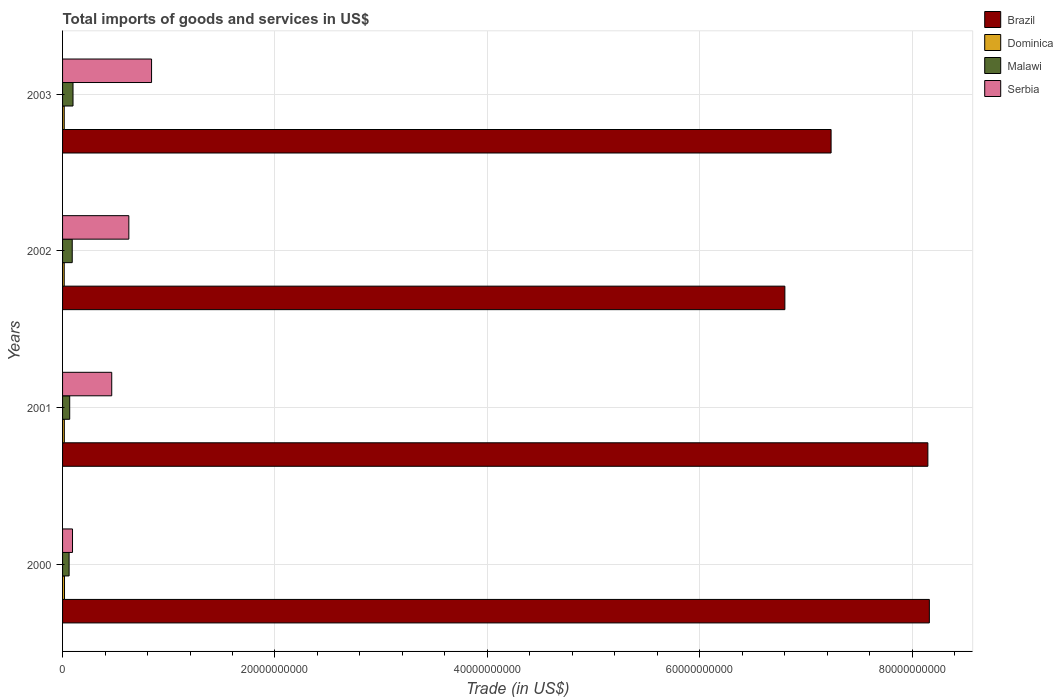How many bars are there on the 3rd tick from the top?
Give a very brief answer. 4. In how many cases, is the number of bars for a given year not equal to the number of legend labels?
Your answer should be compact. 0. What is the total imports of goods and services in Malawi in 2002?
Your answer should be very brief. 9.10e+08. Across all years, what is the maximum total imports of goods and services in Serbia?
Give a very brief answer. 8.38e+09. Across all years, what is the minimum total imports of goods and services in Serbia?
Provide a succinct answer. 9.36e+08. In which year was the total imports of goods and services in Malawi maximum?
Offer a terse response. 2003. What is the total total imports of goods and services in Serbia in the graph?
Give a very brief answer. 2.02e+1. What is the difference between the total imports of goods and services in Dominica in 2002 and that in 2003?
Ensure brevity in your answer.  -1.10e+06. What is the difference between the total imports of goods and services in Serbia in 2001 and the total imports of goods and services in Malawi in 2002?
Offer a terse response. 3.72e+09. What is the average total imports of goods and services in Malawi per year?
Your response must be concise. 7.96e+08. In the year 2001, what is the difference between the total imports of goods and services in Dominica and total imports of goods and services in Serbia?
Offer a very short reply. -4.46e+09. What is the ratio of the total imports of goods and services in Malawi in 2000 to that in 2003?
Give a very brief answer. 0.63. Is the total imports of goods and services in Dominica in 2000 less than that in 2001?
Provide a succinct answer. No. Is the difference between the total imports of goods and services in Dominica in 2001 and 2002 greater than the difference between the total imports of goods and services in Serbia in 2001 and 2002?
Offer a terse response. Yes. What is the difference between the highest and the second highest total imports of goods and services in Dominica?
Give a very brief answer. 1.73e+07. What is the difference between the highest and the lowest total imports of goods and services in Serbia?
Ensure brevity in your answer.  7.44e+09. Is the sum of the total imports of goods and services in Serbia in 2000 and 2002 greater than the maximum total imports of goods and services in Brazil across all years?
Your answer should be compact. No. Is it the case that in every year, the sum of the total imports of goods and services in Brazil and total imports of goods and services in Malawi is greater than the sum of total imports of goods and services in Serbia and total imports of goods and services in Dominica?
Provide a short and direct response. Yes. What does the 1st bar from the top in 2000 represents?
Provide a succinct answer. Serbia. What does the 2nd bar from the bottom in 2001 represents?
Make the answer very short. Dominica. How many bars are there?
Offer a terse response. 16. Are all the bars in the graph horizontal?
Provide a succinct answer. Yes. What is the difference between two consecutive major ticks on the X-axis?
Offer a terse response. 2.00e+1. Does the graph contain any zero values?
Provide a short and direct response. No. Where does the legend appear in the graph?
Offer a terse response. Top right. How many legend labels are there?
Make the answer very short. 4. What is the title of the graph?
Offer a terse response. Total imports of goods and services in US$. Does "Nicaragua" appear as one of the legend labels in the graph?
Make the answer very short. No. What is the label or title of the X-axis?
Your response must be concise. Trade (in US$). What is the label or title of the Y-axis?
Ensure brevity in your answer.  Years. What is the Trade (in US$) in Brazil in 2000?
Your answer should be compact. 8.16e+1. What is the Trade (in US$) of Dominica in 2000?
Give a very brief answer. 1.83e+08. What is the Trade (in US$) in Malawi in 2000?
Give a very brief answer. 6.16e+08. What is the Trade (in US$) in Serbia in 2000?
Provide a succinct answer. 9.36e+08. What is the Trade (in US$) of Brazil in 2001?
Offer a very short reply. 8.15e+1. What is the Trade (in US$) of Dominica in 2001?
Your answer should be compact. 1.66e+08. What is the Trade (in US$) of Malawi in 2001?
Ensure brevity in your answer.  6.72e+08. What is the Trade (in US$) in Serbia in 2001?
Your response must be concise. 4.63e+09. What is the Trade (in US$) in Brazil in 2002?
Make the answer very short. 6.80e+1. What is the Trade (in US$) in Dominica in 2002?
Offer a terse response. 1.56e+08. What is the Trade (in US$) of Malawi in 2002?
Give a very brief answer. 9.10e+08. What is the Trade (in US$) in Serbia in 2002?
Your response must be concise. 6.24e+09. What is the Trade (in US$) of Brazil in 2003?
Ensure brevity in your answer.  7.24e+1. What is the Trade (in US$) of Dominica in 2003?
Make the answer very short. 1.57e+08. What is the Trade (in US$) in Malawi in 2003?
Your answer should be compact. 9.84e+08. What is the Trade (in US$) of Serbia in 2003?
Offer a terse response. 8.38e+09. Across all years, what is the maximum Trade (in US$) in Brazil?
Your response must be concise. 8.16e+1. Across all years, what is the maximum Trade (in US$) of Dominica?
Make the answer very short. 1.83e+08. Across all years, what is the maximum Trade (in US$) in Malawi?
Ensure brevity in your answer.  9.84e+08. Across all years, what is the maximum Trade (in US$) in Serbia?
Offer a terse response. 8.38e+09. Across all years, what is the minimum Trade (in US$) in Brazil?
Ensure brevity in your answer.  6.80e+1. Across all years, what is the minimum Trade (in US$) in Dominica?
Keep it short and to the point. 1.56e+08. Across all years, what is the minimum Trade (in US$) in Malawi?
Provide a succinct answer. 6.16e+08. Across all years, what is the minimum Trade (in US$) of Serbia?
Give a very brief answer. 9.36e+08. What is the total Trade (in US$) in Brazil in the graph?
Ensure brevity in your answer.  3.03e+11. What is the total Trade (in US$) of Dominica in the graph?
Your response must be concise. 6.62e+08. What is the total Trade (in US$) of Malawi in the graph?
Give a very brief answer. 3.18e+09. What is the total Trade (in US$) of Serbia in the graph?
Provide a succinct answer. 2.02e+1. What is the difference between the Trade (in US$) of Brazil in 2000 and that in 2001?
Your response must be concise. 1.39e+08. What is the difference between the Trade (in US$) of Dominica in 2000 and that in 2001?
Offer a very short reply. 1.73e+07. What is the difference between the Trade (in US$) of Malawi in 2000 and that in 2001?
Offer a very short reply. -5.56e+07. What is the difference between the Trade (in US$) of Serbia in 2000 and that in 2001?
Your answer should be very brief. -3.69e+09. What is the difference between the Trade (in US$) in Brazil in 2000 and that in 2002?
Your answer should be compact. 1.36e+1. What is the difference between the Trade (in US$) in Dominica in 2000 and that in 2002?
Your answer should be compact. 2.68e+07. What is the difference between the Trade (in US$) of Malawi in 2000 and that in 2002?
Your answer should be compact. -2.94e+08. What is the difference between the Trade (in US$) in Serbia in 2000 and that in 2002?
Keep it short and to the point. -5.30e+09. What is the difference between the Trade (in US$) in Brazil in 2000 and that in 2003?
Give a very brief answer. 9.25e+09. What is the difference between the Trade (in US$) of Dominica in 2000 and that in 2003?
Keep it short and to the point. 2.57e+07. What is the difference between the Trade (in US$) in Malawi in 2000 and that in 2003?
Offer a very short reply. -3.68e+08. What is the difference between the Trade (in US$) of Serbia in 2000 and that in 2003?
Your response must be concise. -7.44e+09. What is the difference between the Trade (in US$) of Brazil in 2001 and that in 2002?
Your response must be concise. 1.35e+1. What is the difference between the Trade (in US$) of Dominica in 2001 and that in 2002?
Keep it short and to the point. 9.51e+06. What is the difference between the Trade (in US$) in Malawi in 2001 and that in 2002?
Provide a short and direct response. -2.39e+08. What is the difference between the Trade (in US$) in Serbia in 2001 and that in 2002?
Offer a very short reply. -1.61e+09. What is the difference between the Trade (in US$) of Brazil in 2001 and that in 2003?
Keep it short and to the point. 9.11e+09. What is the difference between the Trade (in US$) in Dominica in 2001 and that in 2003?
Keep it short and to the point. 8.41e+06. What is the difference between the Trade (in US$) of Malawi in 2001 and that in 2003?
Your response must be concise. -3.13e+08. What is the difference between the Trade (in US$) of Serbia in 2001 and that in 2003?
Give a very brief answer. -3.75e+09. What is the difference between the Trade (in US$) in Brazil in 2002 and that in 2003?
Provide a short and direct response. -4.35e+09. What is the difference between the Trade (in US$) in Dominica in 2002 and that in 2003?
Your answer should be very brief. -1.10e+06. What is the difference between the Trade (in US$) of Malawi in 2002 and that in 2003?
Your answer should be compact. -7.41e+07. What is the difference between the Trade (in US$) in Serbia in 2002 and that in 2003?
Give a very brief answer. -2.14e+09. What is the difference between the Trade (in US$) in Brazil in 2000 and the Trade (in US$) in Dominica in 2001?
Your answer should be very brief. 8.15e+1. What is the difference between the Trade (in US$) of Brazil in 2000 and the Trade (in US$) of Malawi in 2001?
Offer a terse response. 8.09e+1. What is the difference between the Trade (in US$) of Brazil in 2000 and the Trade (in US$) of Serbia in 2001?
Give a very brief answer. 7.70e+1. What is the difference between the Trade (in US$) of Dominica in 2000 and the Trade (in US$) of Malawi in 2001?
Keep it short and to the point. -4.89e+08. What is the difference between the Trade (in US$) in Dominica in 2000 and the Trade (in US$) in Serbia in 2001?
Give a very brief answer. -4.45e+09. What is the difference between the Trade (in US$) of Malawi in 2000 and the Trade (in US$) of Serbia in 2001?
Give a very brief answer. -4.01e+09. What is the difference between the Trade (in US$) of Brazil in 2000 and the Trade (in US$) of Dominica in 2002?
Give a very brief answer. 8.15e+1. What is the difference between the Trade (in US$) of Brazil in 2000 and the Trade (in US$) of Malawi in 2002?
Ensure brevity in your answer.  8.07e+1. What is the difference between the Trade (in US$) in Brazil in 2000 and the Trade (in US$) in Serbia in 2002?
Offer a terse response. 7.54e+1. What is the difference between the Trade (in US$) in Dominica in 2000 and the Trade (in US$) in Malawi in 2002?
Your answer should be very brief. -7.27e+08. What is the difference between the Trade (in US$) in Dominica in 2000 and the Trade (in US$) in Serbia in 2002?
Your answer should be compact. -6.06e+09. What is the difference between the Trade (in US$) of Malawi in 2000 and the Trade (in US$) of Serbia in 2002?
Ensure brevity in your answer.  -5.63e+09. What is the difference between the Trade (in US$) of Brazil in 2000 and the Trade (in US$) of Dominica in 2003?
Your answer should be compact. 8.15e+1. What is the difference between the Trade (in US$) in Brazil in 2000 and the Trade (in US$) in Malawi in 2003?
Provide a short and direct response. 8.06e+1. What is the difference between the Trade (in US$) of Brazil in 2000 and the Trade (in US$) of Serbia in 2003?
Keep it short and to the point. 7.32e+1. What is the difference between the Trade (in US$) of Dominica in 2000 and the Trade (in US$) of Malawi in 2003?
Your response must be concise. -8.01e+08. What is the difference between the Trade (in US$) in Dominica in 2000 and the Trade (in US$) in Serbia in 2003?
Ensure brevity in your answer.  -8.20e+09. What is the difference between the Trade (in US$) of Malawi in 2000 and the Trade (in US$) of Serbia in 2003?
Make the answer very short. -7.76e+09. What is the difference between the Trade (in US$) of Brazil in 2001 and the Trade (in US$) of Dominica in 2002?
Give a very brief answer. 8.13e+1. What is the difference between the Trade (in US$) of Brazil in 2001 and the Trade (in US$) of Malawi in 2002?
Your answer should be compact. 8.06e+1. What is the difference between the Trade (in US$) in Brazil in 2001 and the Trade (in US$) in Serbia in 2002?
Keep it short and to the point. 7.52e+1. What is the difference between the Trade (in US$) of Dominica in 2001 and the Trade (in US$) of Malawi in 2002?
Give a very brief answer. -7.45e+08. What is the difference between the Trade (in US$) of Dominica in 2001 and the Trade (in US$) of Serbia in 2002?
Ensure brevity in your answer.  -6.08e+09. What is the difference between the Trade (in US$) of Malawi in 2001 and the Trade (in US$) of Serbia in 2002?
Provide a short and direct response. -5.57e+09. What is the difference between the Trade (in US$) of Brazil in 2001 and the Trade (in US$) of Dominica in 2003?
Your answer should be compact. 8.13e+1. What is the difference between the Trade (in US$) in Brazil in 2001 and the Trade (in US$) in Malawi in 2003?
Ensure brevity in your answer.  8.05e+1. What is the difference between the Trade (in US$) of Brazil in 2001 and the Trade (in US$) of Serbia in 2003?
Your answer should be compact. 7.31e+1. What is the difference between the Trade (in US$) of Dominica in 2001 and the Trade (in US$) of Malawi in 2003?
Give a very brief answer. -8.19e+08. What is the difference between the Trade (in US$) of Dominica in 2001 and the Trade (in US$) of Serbia in 2003?
Keep it short and to the point. -8.21e+09. What is the difference between the Trade (in US$) in Malawi in 2001 and the Trade (in US$) in Serbia in 2003?
Offer a terse response. -7.71e+09. What is the difference between the Trade (in US$) in Brazil in 2002 and the Trade (in US$) in Dominica in 2003?
Make the answer very short. 6.79e+1. What is the difference between the Trade (in US$) of Brazil in 2002 and the Trade (in US$) of Malawi in 2003?
Make the answer very short. 6.70e+1. What is the difference between the Trade (in US$) in Brazil in 2002 and the Trade (in US$) in Serbia in 2003?
Your response must be concise. 5.96e+1. What is the difference between the Trade (in US$) of Dominica in 2002 and the Trade (in US$) of Malawi in 2003?
Provide a succinct answer. -8.28e+08. What is the difference between the Trade (in US$) of Dominica in 2002 and the Trade (in US$) of Serbia in 2003?
Offer a terse response. -8.22e+09. What is the difference between the Trade (in US$) of Malawi in 2002 and the Trade (in US$) of Serbia in 2003?
Keep it short and to the point. -7.47e+09. What is the average Trade (in US$) of Brazil per year?
Offer a terse response. 7.59e+1. What is the average Trade (in US$) in Dominica per year?
Give a very brief answer. 1.66e+08. What is the average Trade (in US$) in Malawi per year?
Your answer should be compact. 7.96e+08. What is the average Trade (in US$) in Serbia per year?
Your answer should be very brief. 5.05e+09. In the year 2000, what is the difference between the Trade (in US$) of Brazil and Trade (in US$) of Dominica?
Provide a succinct answer. 8.14e+1. In the year 2000, what is the difference between the Trade (in US$) in Brazil and Trade (in US$) in Malawi?
Your answer should be very brief. 8.10e+1. In the year 2000, what is the difference between the Trade (in US$) of Brazil and Trade (in US$) of Serbia?
Your answer should be very brief. 8.07e+1. In the year 2000, what is the difference between the Trade (in US$) in Dominica and Trade (in US$) in Malawi?
Provide a short and direct response. -4.33e+08. In the year 2000, what is the difference between the Trade (in US$) in Dominica and Trade (in US$) in Serbia?
Provide a short and direct response. -7.53e+08. In the year 2000, what is the difference between the Trade (in US$) in Malawi and Trade (in US$) in Serbia?
Keep it short and to the point. -3.20e+08. In the year 2001, what is the difference between the Trade (in US$) in Brazil and Trade (in US$) in Dominica?
Ensure brevity in your answer.  8.13e+1. In the year 2001, what is the difference between the Trade (in US$) of Brazil and Trade (in US$) of Malawi?
Provide a succinct answer. 8.08e+1. In the year 2001, what is the difference between the Trade (in US$) of Brazil and Trade (in US$) of Serbia?
Offer a very short reply. 7.69e+1. In the year 2001, what is the difference between the Trade (in US$) of Dominica and Trade (in US$) of Malawi?
Your response must be concise. -5.06e+08. In the year 2001, what is the difference between the Trade (in US$) in Dominica and Trade (in US$) in Serbia?
Offer a very short reply. -4.46e+09. In the year 2001, what is the difference between the Trade (in US$) in Malawi and Trade (in US$) in Serbia?
Your answer should be compact. -3.96e+09. In the year 2002, what is the difference between the Trade (in US$) of Brazil and Trade (in US$) of Dominica?
Offer a very short reply. 6.79e+1. In the year 2002, what is the difference between the Trade (in US$) in Brazil and Trade (in US$) in Malawi?
Offer a very short reply. 6.71e+1. In the year 2002, what is the difference between the Trade (in US$) of Brazil and Trade (in US$) of Serbia?
Offer a terse response. 6.18e+1. In the year 2002, what is the difference between the Trade (in US$) of Dominica and Trade (in US$) of Malawi?
Your answer should be very brief. -7.54e+08. In the year 2002, what is the difference between the Trade (in US$) of Dominica and Trade (in US$) of Serbia?
Offer a terse response. -6.09e+09. In the year 2002, what is the difference between the Trade (in US$) of Malawi and Trade (in US$) of Serbia?
Your response must be concise. -5.33e+09. In the year 2003, what is the difference between the Trade (in US$) of Brazil and Trade (in US$) of Dominica?
Give a very brief answer. 7.22e+1. In the year 2003, what is the difference between the Trade (in US$) of Brazil and Trade (in US$) of Malawi?
Give a very brief answer. 7.14e+1. In the year 2003, what is the difference between the Trade (in US$) of Brazil and Trade (in US$) of Serbia?
Ensure brevity in your answer.  6.40e+1. In the year 2003, what is the difference between the Trade (in US$) of Dominica and Trade (in US$) of Malawi?
Give a very brief answer. -8.27e+08. In the year 2003, what is the difference between the Trade (in US$) of Dominica and Trade (in US$) of Serbia?
Provide a succinct answer. -8.22e+09. In the year 2003, what is the difference between the Trade (in US$) in Malawi and Trade (in US$) in Serbia?
Your answer should be very brief. -7.40e+09. What is the ratio of the Trade (in US$) of Brazil in 2000 to that in 2001?
Give a very brief answer. 1. What is the ratio of the Trade (in US$) of Dominica in 2000 to that in 2001?
Provide a succinct answer. 1.1. What is the ratio of the Trade (in US$) of Malawi in 2000 to that in 2001?
Provide a succinct answer. 0.92. What is the ratio of the Trade (in US$) in Serbia in 2000 to that in 2001?
Give a very brief answer. 0.2. What is the ratio of the Trade (in US$) in Dominica in 2000 to that in 2002?
Make the answer very short. 1.17. What is the ratio of the Trade (in US$) of Malawi in 2000 to that in 2002?
Your answer should be compact. 0.68. What is the ratio of the Trade (in US$) in Brazil in 2000 to that in 2003?
Make the answer very short. 1.13. What is the ratio of the Trade (in US$) in Dominica in 2000 to that in 2003?
Ensure brevity in your answer.  1.16. What is the ratio of the Trade (in US$) of Malawi in 2000 to that in 2003?
Make the answer very short. 0.63. What is the ratio of the Trade (in US$) in Serbia in 2000 to that in 2003?
Offer a very short reply. 0.11. What is the ratio of the Trade (in US$) of Brazil in 2001 to that in 2002?
Make the answer very short. 1.2. What is the ratio of the Trade (in US$) in Dominica in 2001 to that in 2002?
Ensure brevity in your answer.  1.06. What is the ratio of the Trade (in US$) in Malawi in 2001 to that in 2002?
Provide a succinct answer. 0.74. What is the ratio of the Trade (in US$) in Serbia in 2001 to that in 2002?
Your response must be concise. 0.74. What is the ratio of the Trade (in US$) of Brazil in 2001 to that in 2003?
Offer a terse response. 1.13. What is the ratio of the Trade (in US$) in Dominica in 2001 to that in 2003?
Your response must be concise. 1.05. What is the ratio of the Trade (in US$) of Malawi in 2001 to that in 2003?
Give a very brief answer. 0.68. What is the ratio of the Trade (in US$) in Serbia in 2001 to that in 2003?
Your answer should be compact. 0.55. What is the ratio of the Trade (in US$) in Brazil in 2002 to that in 2003?
Provide a short and direct response. 0.94. What is the ratio of the Trade (in US$) of Dominica in 2002 to that in 2003?
Your answer should be compact. 0.99. What is the ratio of the Trade (in US$) of Malawi in 2002 to that in 2003?
Give a very brief answer. 0.92. What is the ratio of the Trade (in US$) of Serbia in 2002 to that in 2003?
Offer a very short reply. 0.74. What is the difference between the highest and the second highest Trade (in US$) in Brazil?
Provide a short and direct response. 1.39e+08. What is the difference between the highest and the second highest Trade (in US$) of Dominica?
Offer a terse response. 1.73e+07. What is the difference between the highest and the second highest Trade (in US$) of Malawi?
Offer a terse response. 7.41e+07. What is the difference between the highest and the second highest Trade (in US$) of Serbia?
Your answer should be compact. 2.14e+09. What is the difference between the highest and the lowest Trade (in US$) of Brazil?
Make the answer very short. 1.36e+1. What is the difference between the highest and the lowest Trade (in US$) of Dominica?
Your response must be concise. 2.68e+07. What is the difference between the highest and the lowest Trade (in US$) of Malawi?
Keep it short and to the point. 3.68e+08. What is the difference between the highest and the lowest Trade (in US$) of Serbia?
Offer a very short reply. 7.44e+09. 